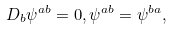Convert formula to latex. <formula><loc_0><loc_0><loc_500><loc_500>D _ { b } \psi ^ { a b } = 0 , \psi ^ { a b } = \psi ^ { b a } ,</formula> 